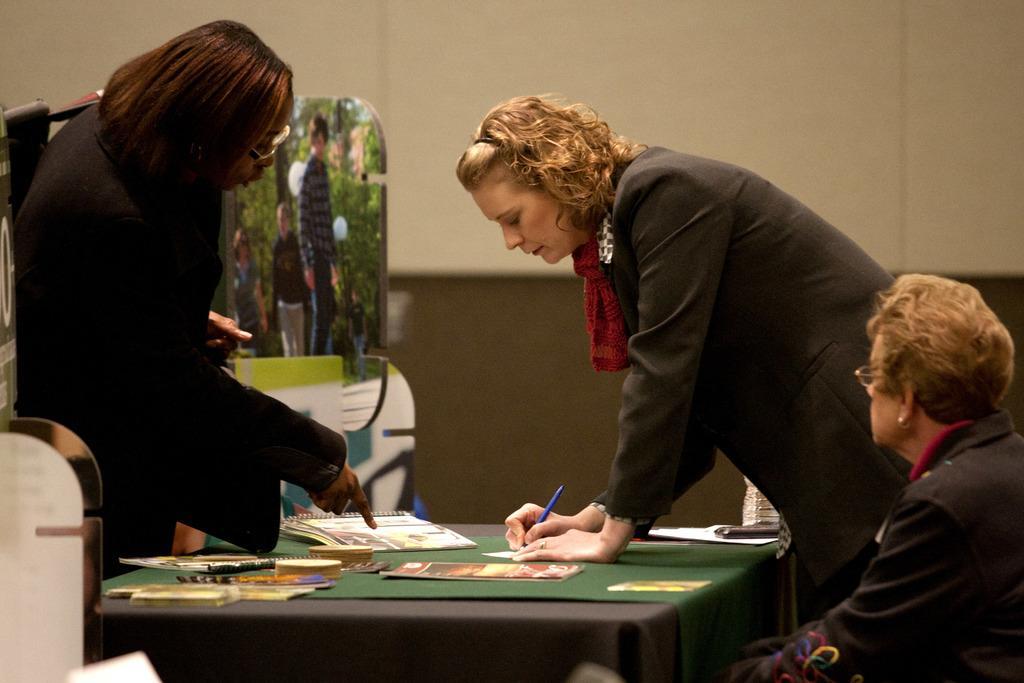Describe this image in one or two sentences. In this picture there are three women two women are standing and one woman is sitting. There is a table on which the on which a green mat is placed and the books are also there. In the background there is a wall with white color. The woman to the right is wearing a black coat. The woman to the left is holding a backpack. 